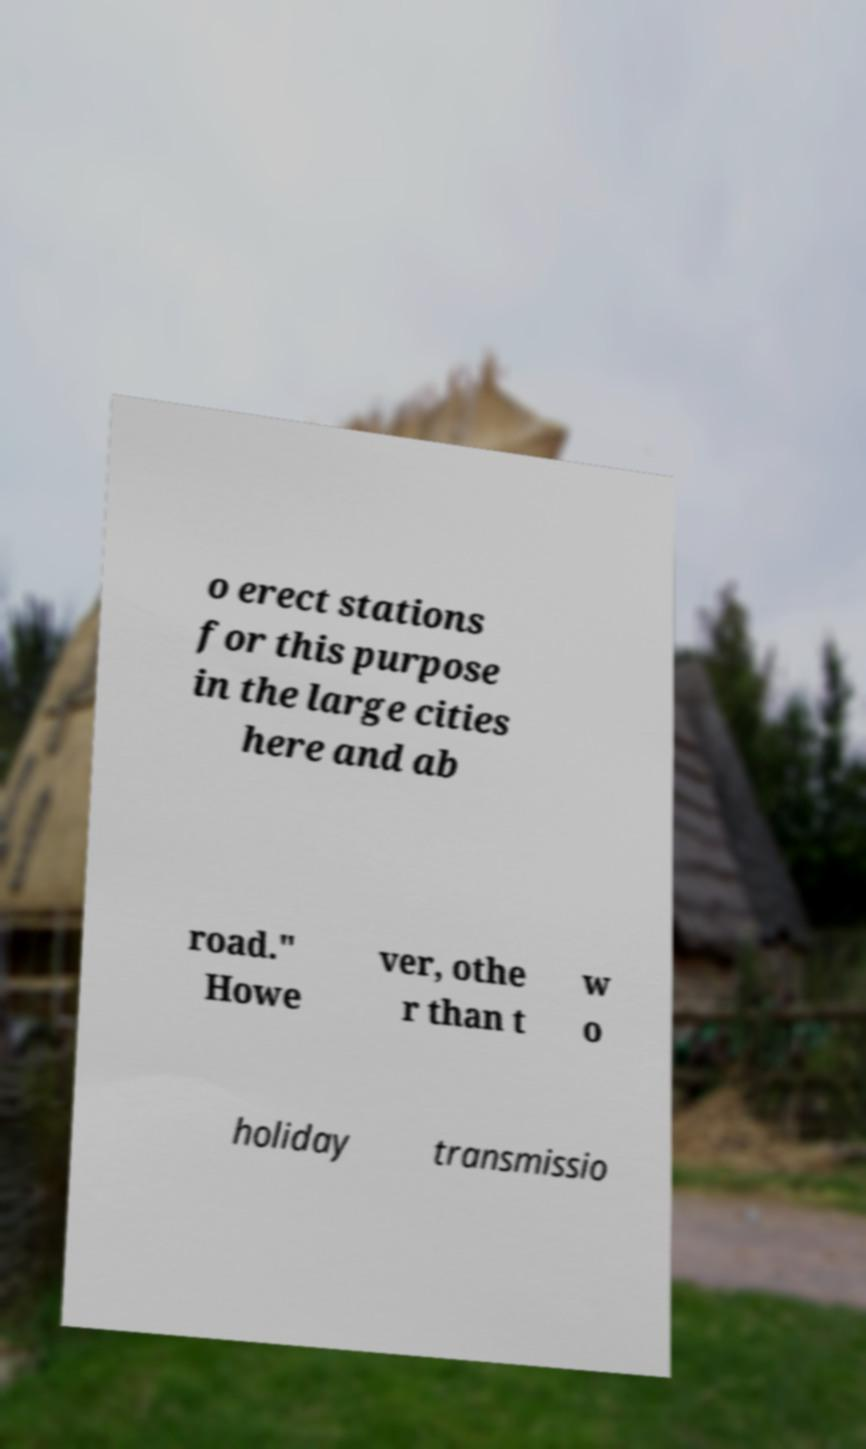Could you extract and type out the text from this image? o erect stations for this purpose in the large cities here and ab road." Howe ver, othe r than t w o holiday transmissio 